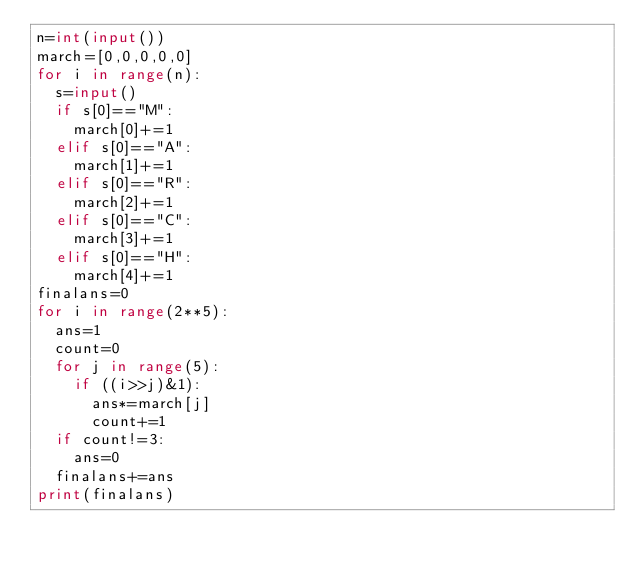Convert code to text. <code><loc_0><loc_0><loc_500><loc_500><_Python_>n=int(input())
march=[0,0,0,0,0]
for i in range(n):
  s=input()
  if s[0]=="M":
    march[0]+=1
  elif s[0]=="A":
    march[1]+=1
  elif s[0]=="R":
    march[2]+=1
  elif s[0]=="C":
    march[3]+=1
  elif s[0]=="H":
    march[4]+=1
finalans=0
for i in range(2**5):
  ans=1
  count=0
  for j in range(5):
    if ((i>>j)&1):
      ans*=march[j]
      count+=1
  if count!=3:
    ans=0
  finalans+=ans
print(finalans)
      </code> 